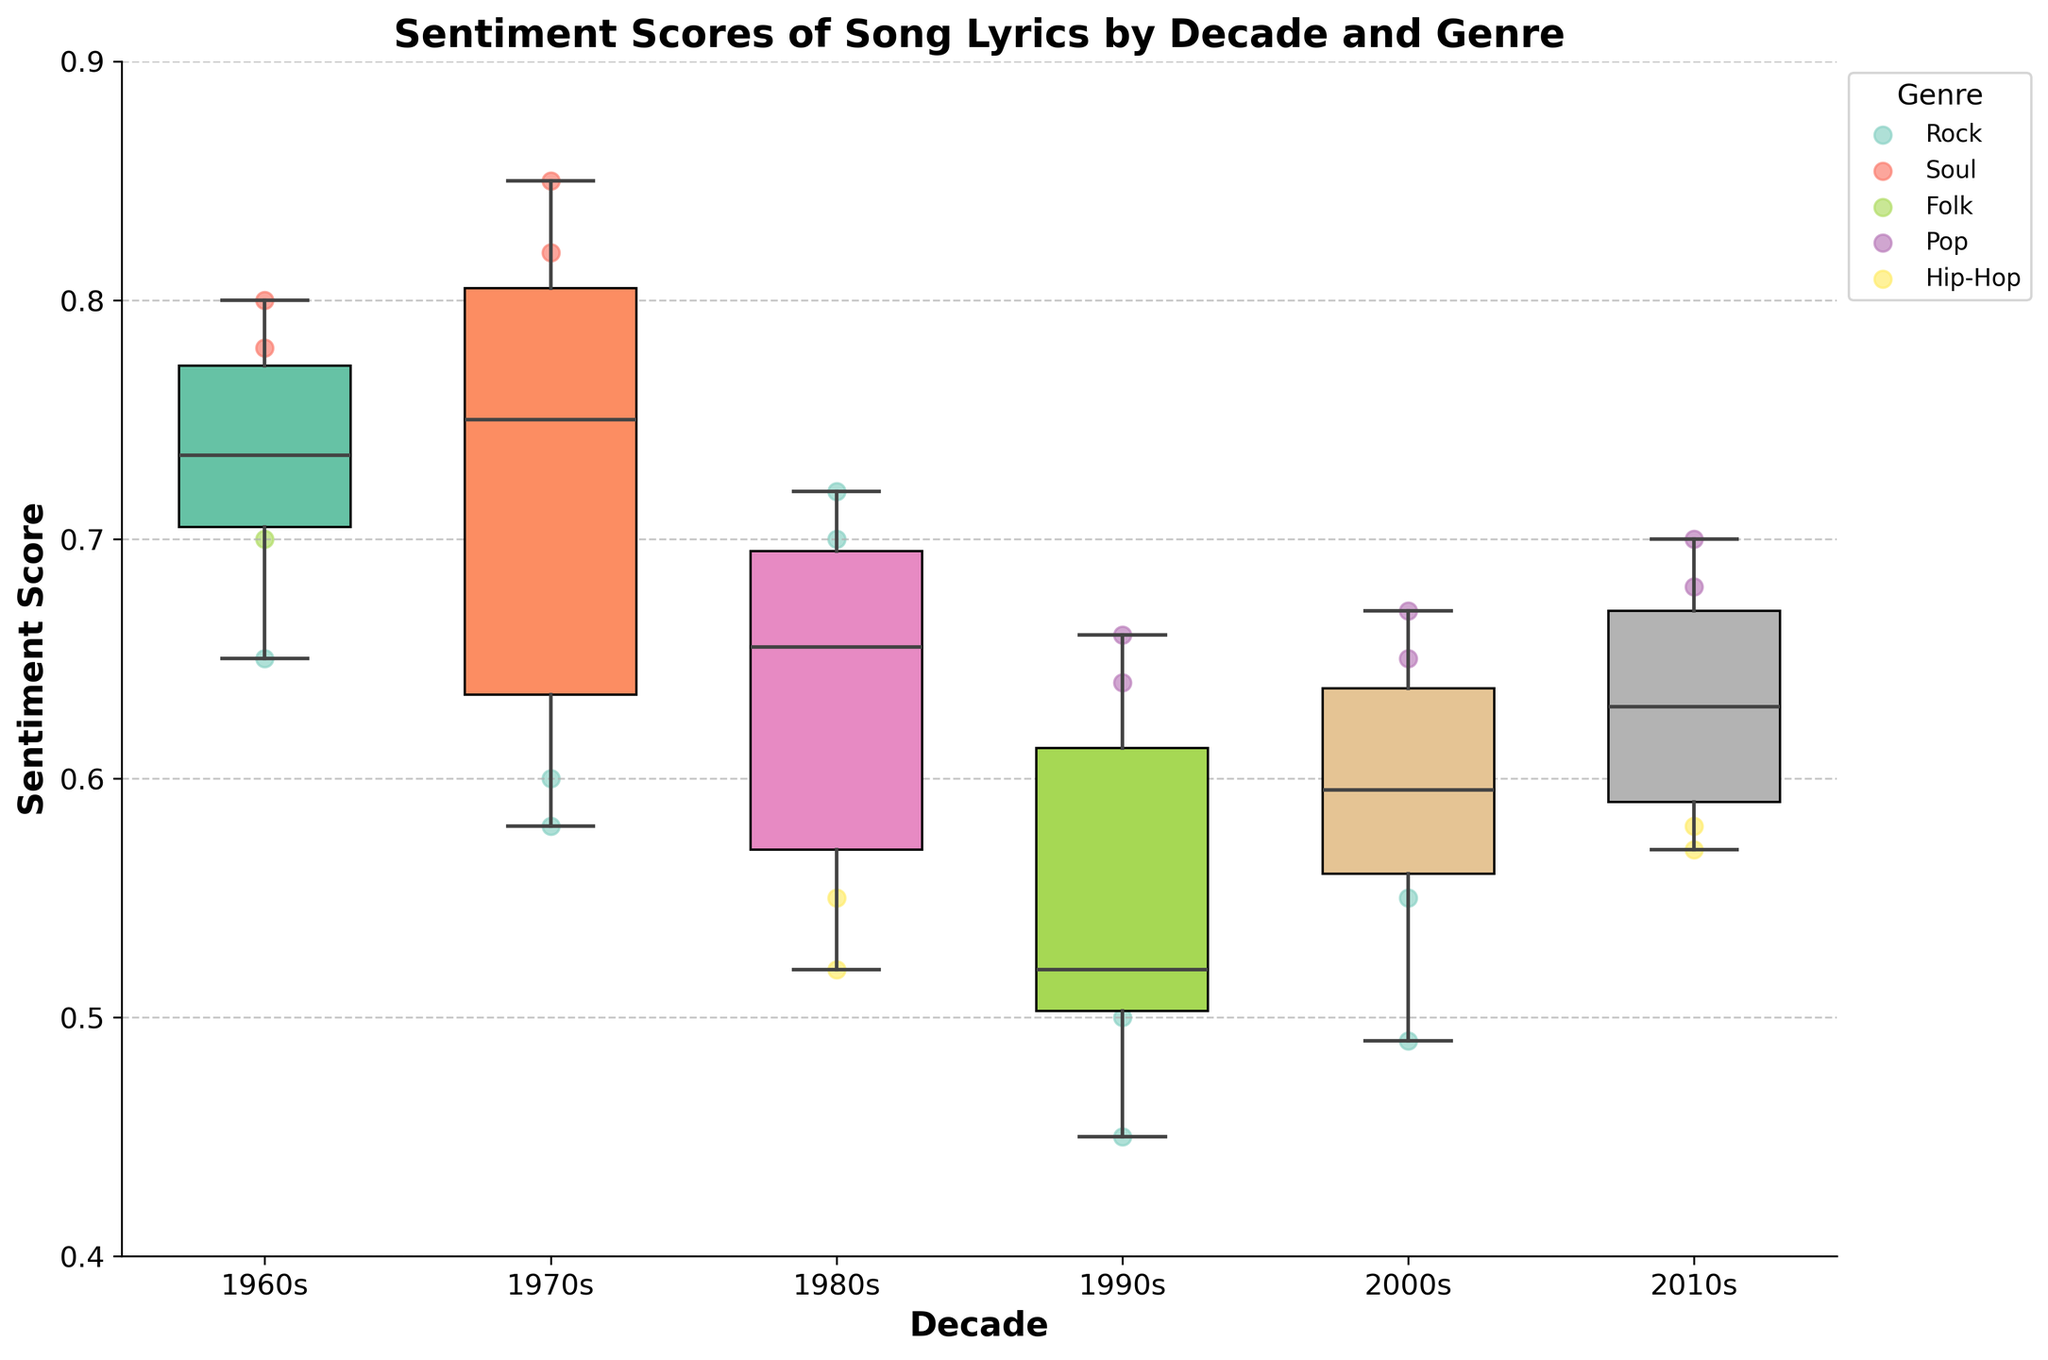What is the title of the figure? The title of the figure is displayed at the top and summarizes the content. It says "Sentiment Scores of Song Lyrics by Decade and Genre".
Answer: Sentiment Scores of Song Lyrics by Decade and Genre Which decade shows the highest median sentiment score? To determine the highest median sentiment score, look at the horizontal line inside each box (representing the median) across all decades. Identify the decade with the highest median line.
Answer: 1970s What genres are represented in the 2010s? Look for scatter points in the 2010s section of the figure and check the colors of these points in the legend to identify represented genres.
Answer: Pop, Hip-Hop, Rock Which genre has the most scatter points in the 1980s? Count the scatter points for each genre within the 1980s section, referring to the legend for color identification.
Answer: Rock How does the sentiment score range for Pop songs in the 2000s compare with Pop songs in the 2010s? Look at the scatter points and box plot ranges for Pop songs in the 2000s and 2010s. Compare the minimum and maximum points for each decade.
Answer: 2000s: 0.65 to 0.67; 2010s: 0.68 to 0.70 Which genre in the 1960s shows the lowest sentiment score? Look at the scatter points in the 1960s and identify which genre has the lowest value by referring to the legend for color coding.
Answer: Rock Which decade shows the greatest variability in sentiment scores? Examine the box plots and identify the decade where the box plot (the distance between Q1 and Q3) is the largest or where the whiskers (range of data) extend the most.
Answer: 1990s Are there any outliers in sentiment scores for Hip-Hop songs in the 2000s? Check the scatter points in the box plot for Hip-Hop songs in the 2000s to see if any points fall outside of the whiskers (extreme values).
Answer: No 